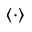<formula> <loc_0><loc_0><loc_500><loc_500>\left < \cdot \right ></formula> 